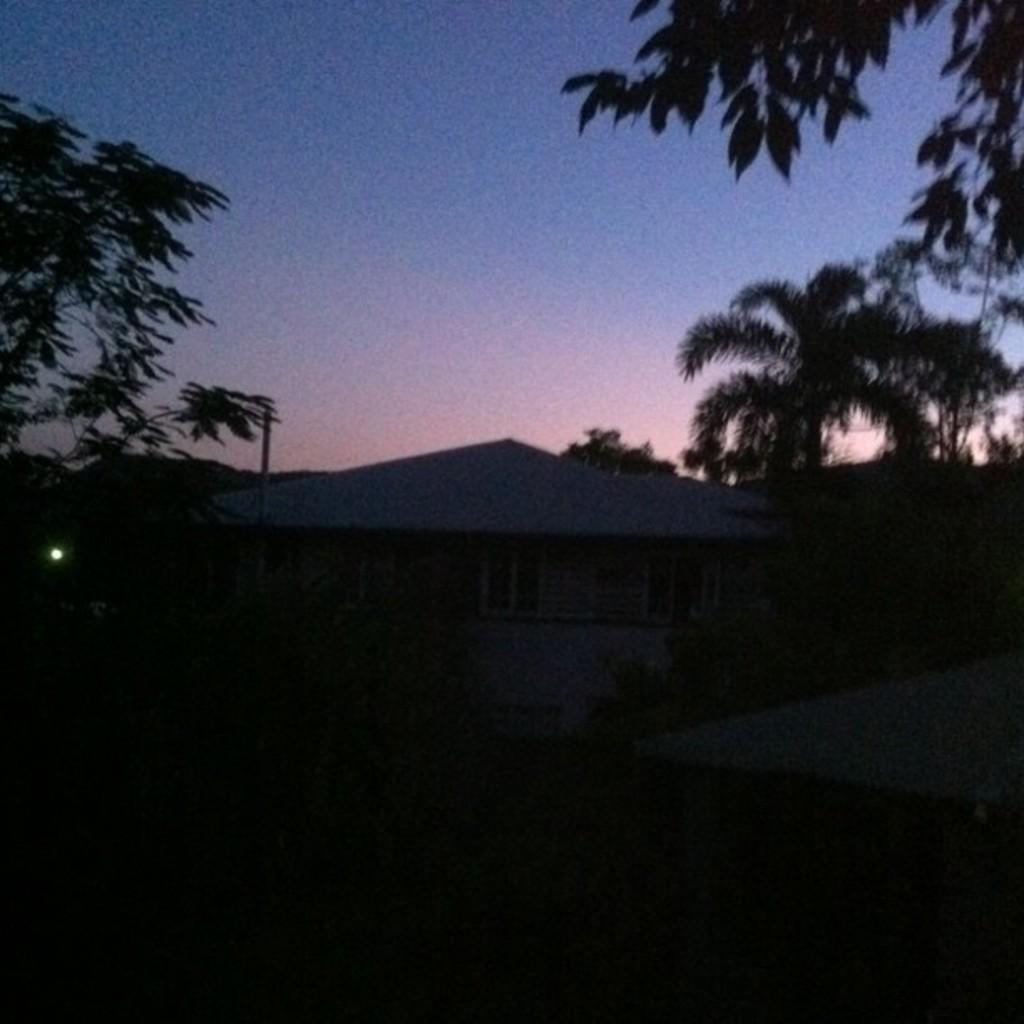Describe this image in one or two sentences. In this image we can see a house, there are some trees and in the background, we can see the sky. 